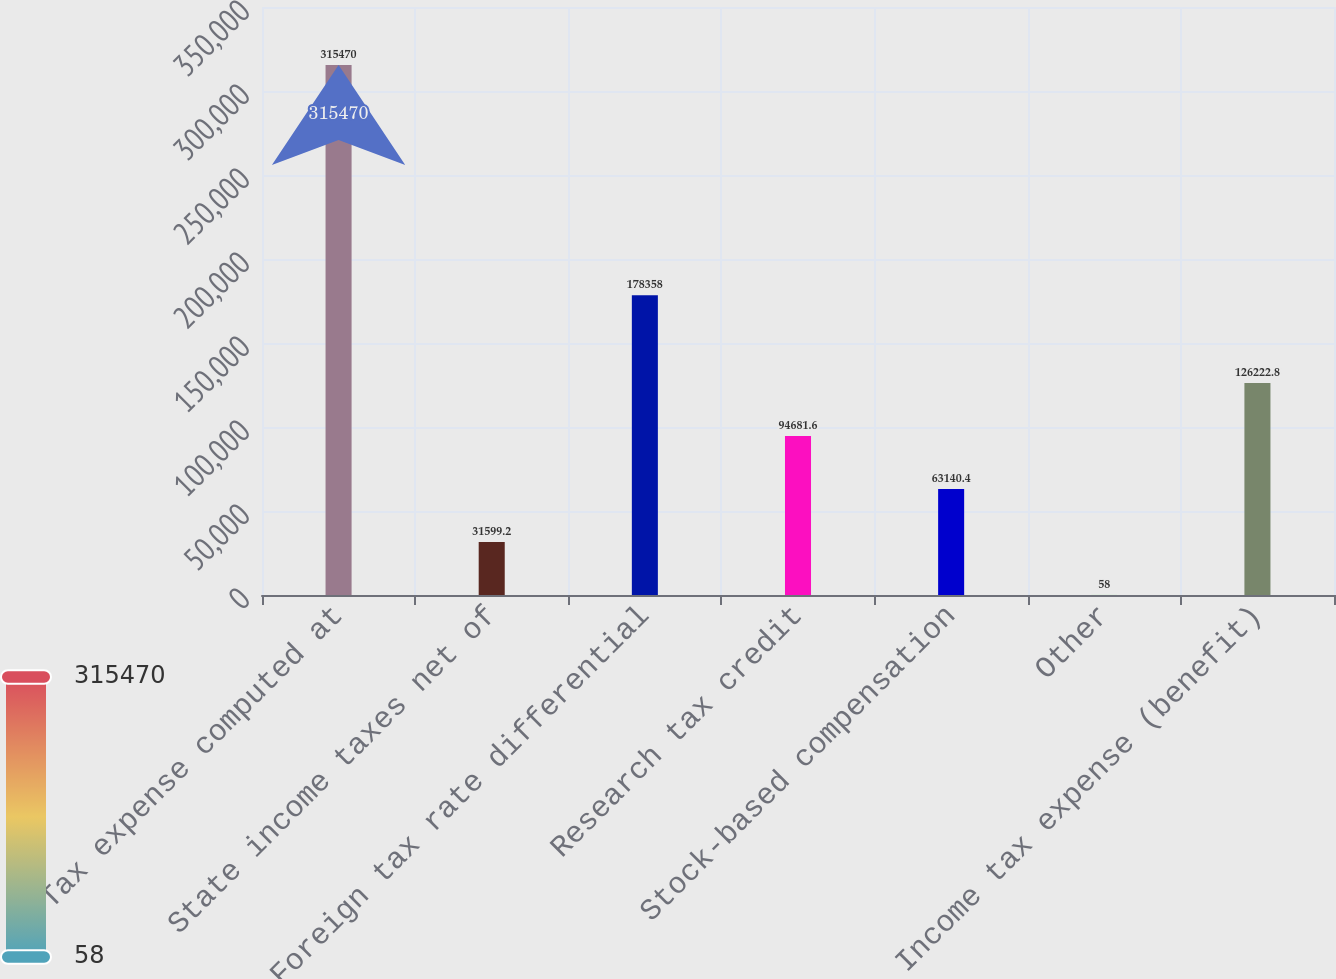Convert chart to OTSL. <chart><loc_0><loc_0><loc_500><loc_500><bar_chart><fcel>Tax expense computed at<fcel>State income taxes net of<fcel>Foreign tax rate differential<fcel>Research tax credit<fcel>Stock-based compensation<fcel>Other<fcel>Income tax expense (benefit)<nl><fcel>315470<fcel>31599.2<fcel>178358<fcel>94681.6<fcel>63140.4<fcel>58<fcel>126223<nl></chart> 